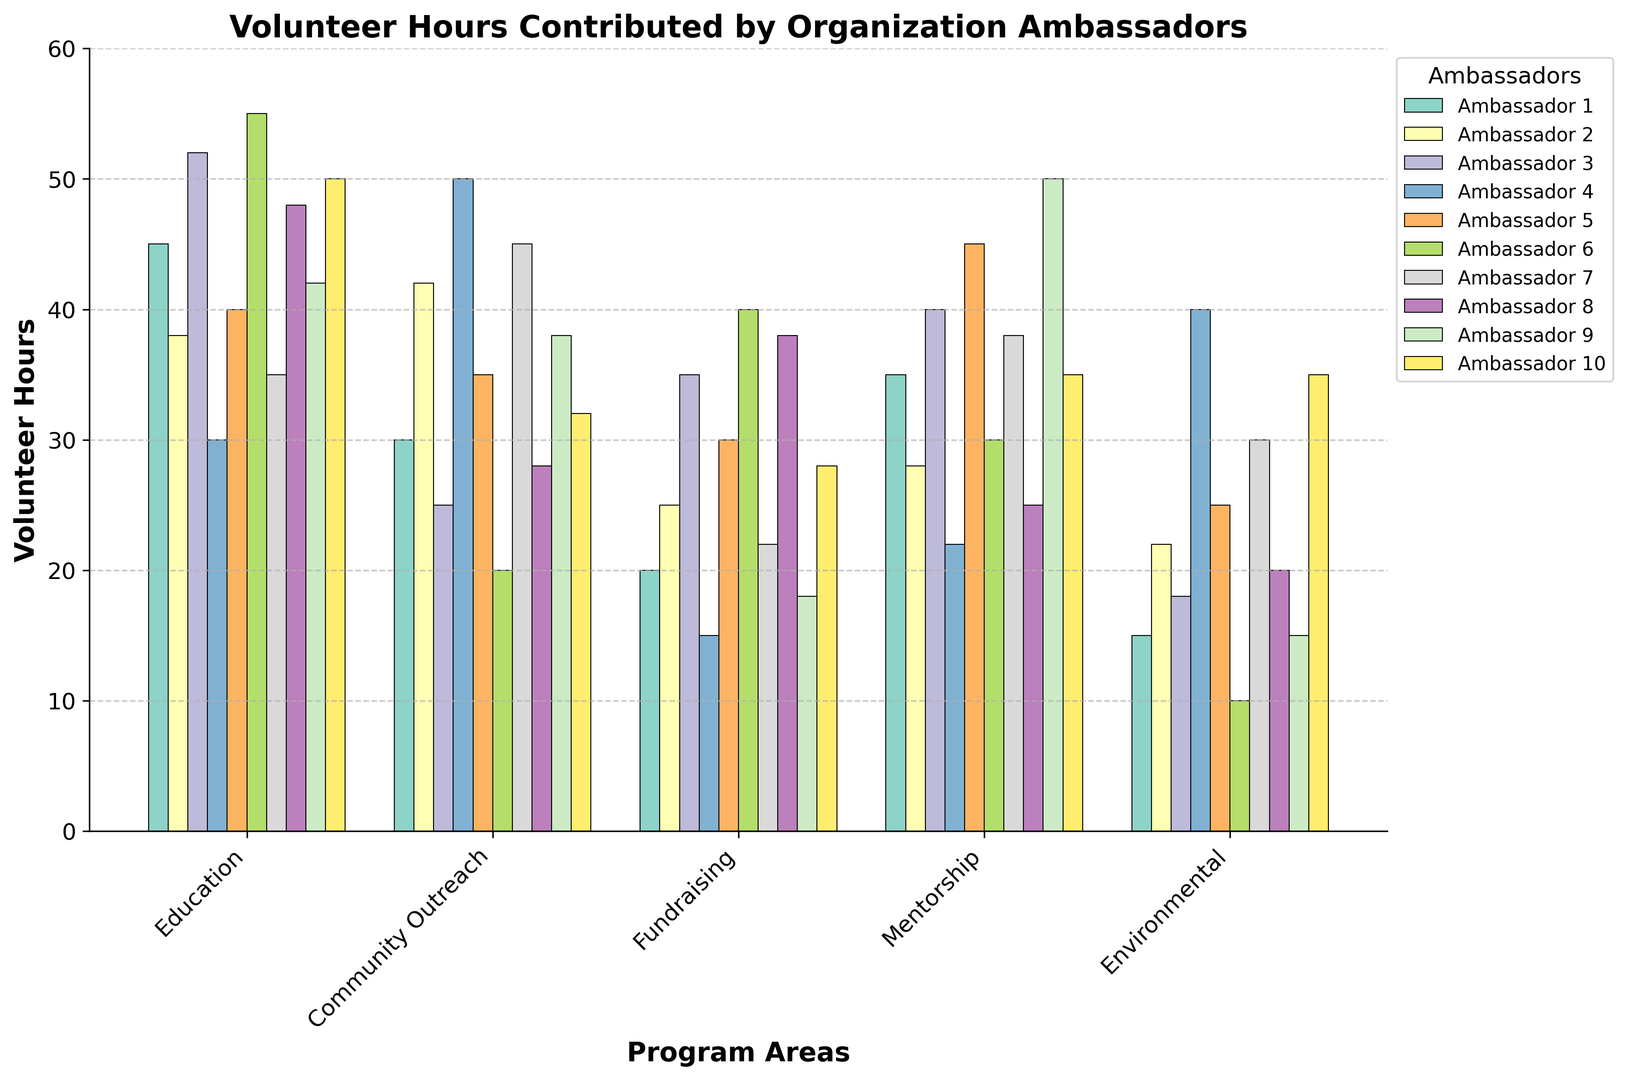How many more volunteer hours did Ambassador 1 contribute to Education compared to Fundraising? Ambassador 1 contributed 45 hours to Education and 20 hours to Fundraising. The difference is 45 - 20 = 25.
Answer: 25 Which program area had the highest total volunteer hours? Sum the hours for each program area across all ambassadors: Education (435), Community Outreach (345), Fundraising (291), Mentorship (348), Environmental (230). Education has the highest total hours of 435.
Answer: Education What is the average number of volunteer hours contributed to Community Outreach per ambassador? Sum the hours for Community Outreach by all ambassadors: 30 + 42 + 25 + 50 + 35 + 20 + 45 + 28 + 38 + 32 = 345. There are 10 ambassadors, so the average is 345 / 10 = 34.5.
Answer: 34.5 Which ambassador has the most balanced distribution of hours across all program areas? Balanced distribution can be inferred by comparing the bars for each ambassador. Ambassador 7 has similar heights across most program areas (35, 45, 22, 38, 30).
Answer: Ambassador 7 Which program area did Ambassador 6 contribute the least hours to? Ambassador 6 contributed 55 hours to Education, 20 hours to Community Outreach, 40 hours to Fundraising, 30 hours to Mentorship, and 10 hours to Environmental. The least is 10 hours to Environmental.
Answer: Environmental How many ambassadors contributed at least 50 hours to any program area? Count the ambassadors with 50 or more hours in at least one program area: Ambassador 3 (Education), Ambassador 4 (Community Outreach), Ambassador 6 (Education), Ambassador 9 (Mentorship), Ambassador 10 (Education). There are 5 such ambassadors.
Answer: 5 What is the difference in total volunteer hours between Fundraising and Environmental program areas? Total hours for Fundraising is 291, and for Environmental is 230. The difference is 291 - 230 = 61.
Answer: 61 For Mentorship, how many more hours did Ambassador 9 contribute compared to Ambassador 4? Ambassador 9 contributed 50 hours and Ambassador 4 contributed 22 hours to Mentorship. The difference is 50 - 22 = 28.
Answer: 28 Which ambassador contributed the highest number of volunteer hours for any single program area, and what was the amount? Ambassador 6 contributed the highest number of hours for Education (55 hours). No other single contribution surpasses 55 hours.
Answer: Ambassador 6, 55 What is the combined total of hours contributed by Ambassadors 2, 4, and 7 to Environmental programs? Add the Environmental hours for Ambassadors 2, 4, and 7: 22 + 40 + 30 = 92.
Answer: 92 